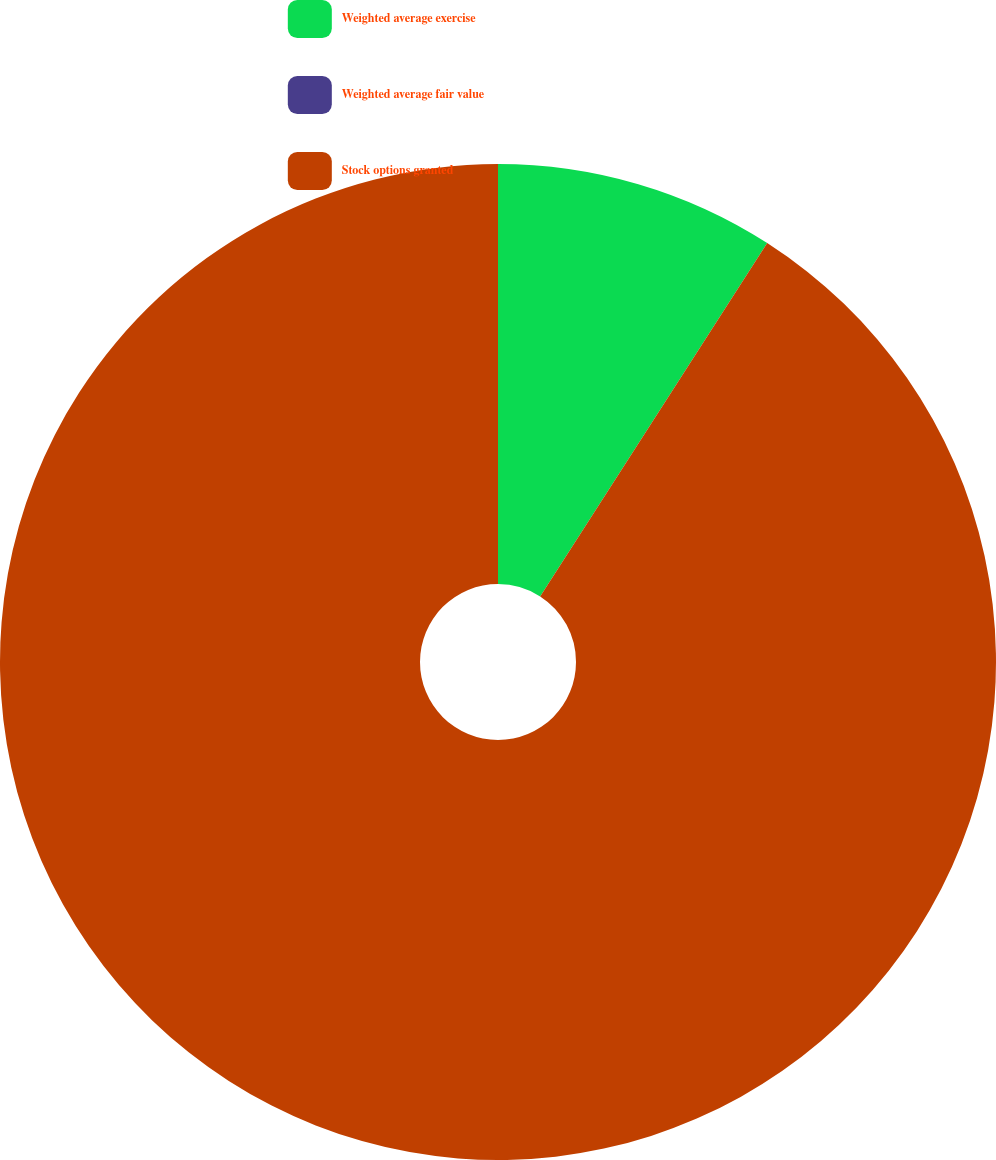Convert chart. <chart><loc_0><loc_0><loc_500><loc_500><pie_chart><fcel>Weighted average exercise<fcel>Weighted average fair value<fcel>Stock options granted<nl><fcel>9.09%<fcel>0.0%<fcel>90.91%<nl></chart> 